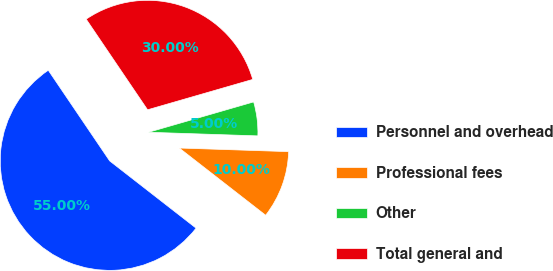Convert chart. <chart><loc_0><loc_0><loc_500><loc_500><pie_chart><fcel>Personnel and overhead<fcel>Professional fees<fcel>Other<fcel>Total general and<nl><fcel>55.0%<fcel>10.0%<fcel>5.0%<fcel>30.0%<nl></chart> 